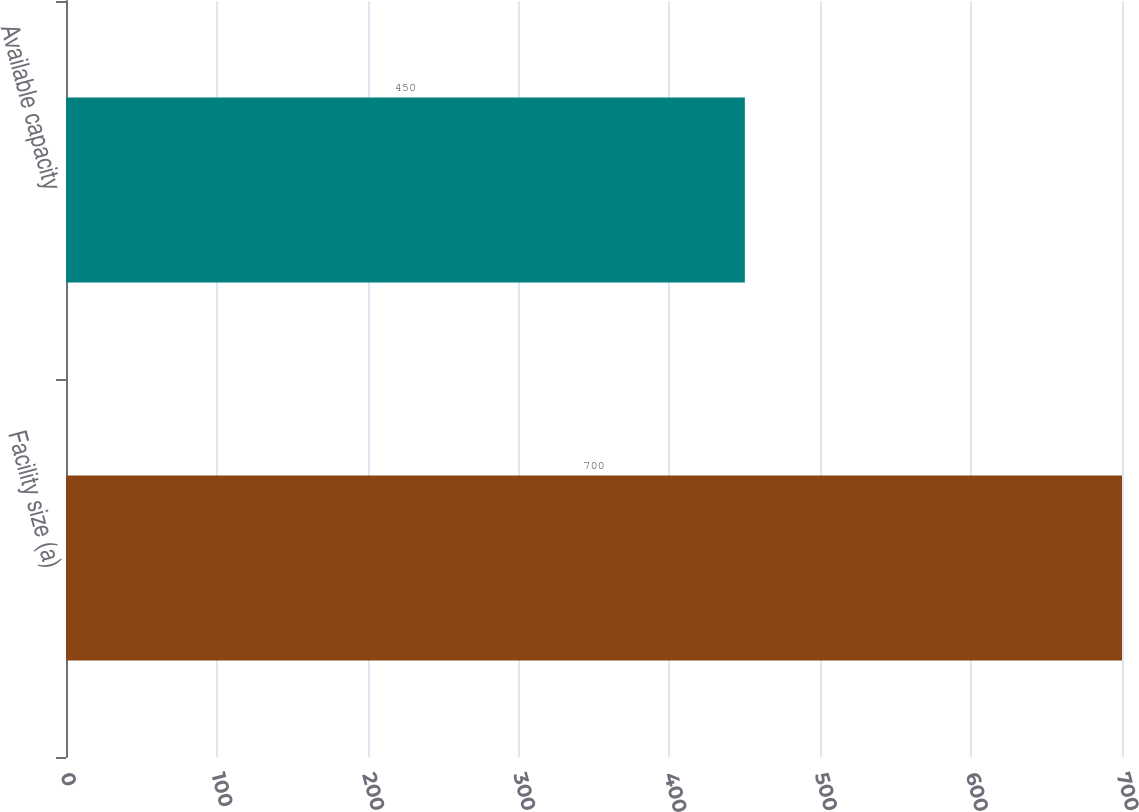<chart> <loc_0><loc_0><loc_500><loc_500><bar_chart><fcel>Facility size (a)<fcel>Available capacity<nl><fcel>700<fcel>450<nl></chart> 